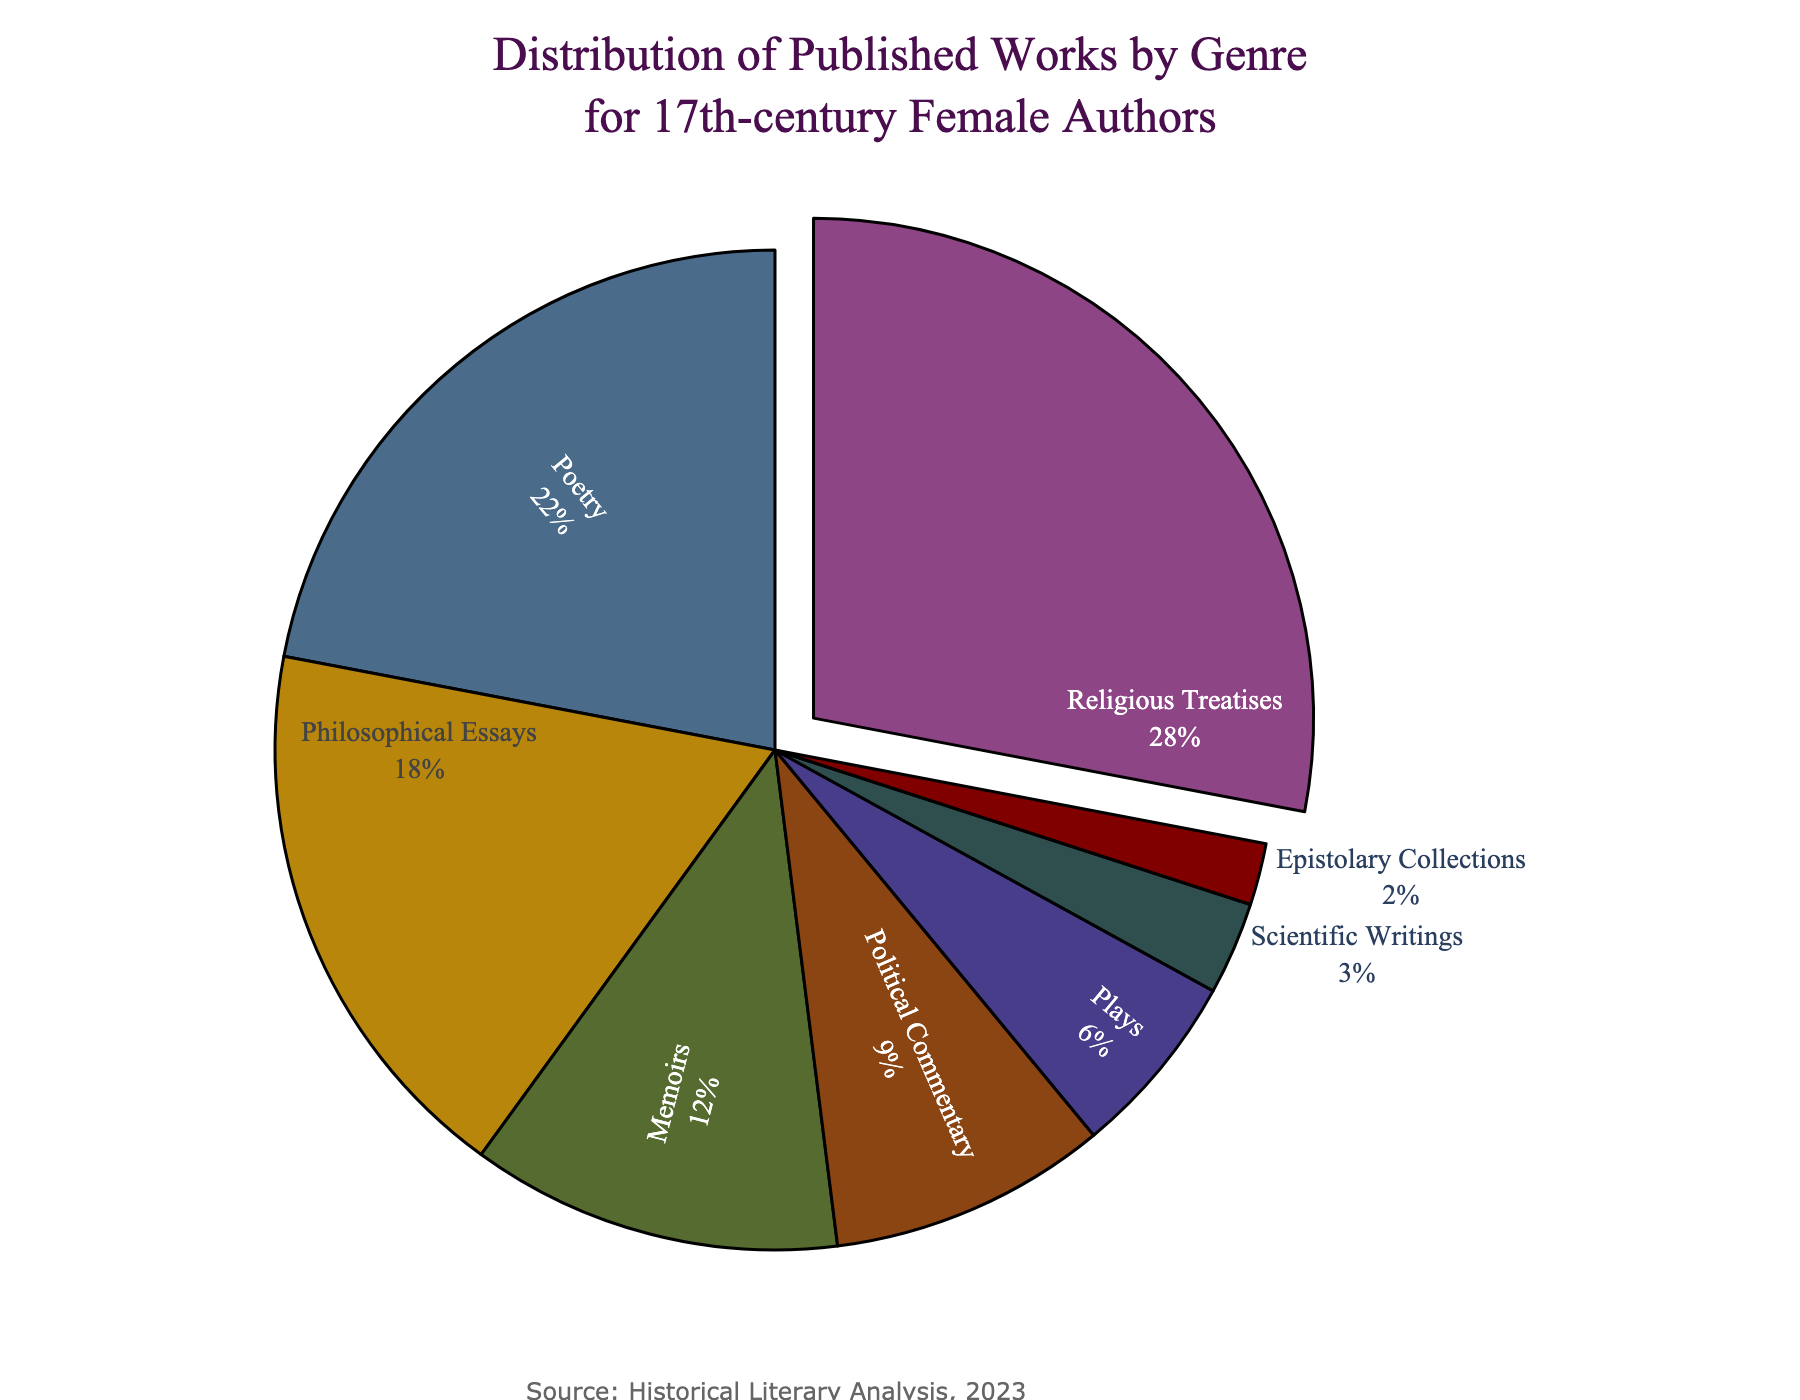What is the genre with the highest percentage of published works? The genre with the highest percentage is visually pulled out in the pie chart and labeled as "Religious Treatises" with 28%.
Answer: Religious Treatises Which genre has the smallest contribution to the distribution of published works? The smallest segment in the pie chart represents "Epistolary Collections" with only 2%.
Answer: Epistolary Collections How much greater is the percentage of Religious Treatises compared to Scientific Writings? The chart shows "Religious Treatises" at 28% and "Scientific Writings" at 3%. The difference is 28% - 3% = 25%.
Answer: 25% What is the combined percentage of Poetry and Philosophical Essays? The chart indicates Poetry is 22% and Philosophical Essays is 18%. Their combined percentage is 22% + 18% = 40%.
Answer: 40% How do Memoirs and Political Commentary compare in terms of their percentage? Memoirs are at 12% and Political Commentary is at 9%. Memoirs have a higher percentage than Political Commentary.
Answer: Memoirs have a higher percentage Which genre is represented by a dark brown color in the chart? Referencing the specific color assigned to each genre, the dark brown segment is labeled as "Political Commentary."
Answer: Political Commentary What's the difference in percentage between Plays and Scientific Writings? The chart shows Plays at 6% and Scientific Writings at 3%. The difference is 6% - 3% = 3%.
Answer: 3% What is the summed percentage of genres that individually contribute less than 10%? Adding the percentages of Political Commentary (9%), Plays (6%), Scientific Writings (3%), and Epistolary Collections (2%): 9% + 6% + 3% + 2% = 20%.
Answer: 20% Which two genres combined make up exactly half (50%) of the distribution of published works? The chart shows that combining Religious Treatises (28%) and Poetry (22%) gives 28% + 22% = 50%.
Answer: Religious Treatises and Poetry 